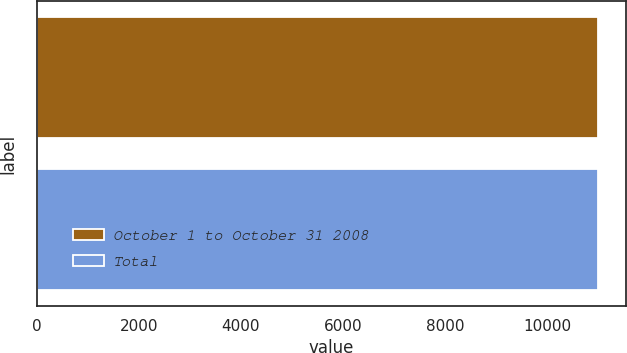Convert chart to OTSL. <chart><loc_0><loc_0><loc_500><loc_500><bar_chart><fcel>October 1 to October 31 2008<fcel>Total<nl><fcel>11000<fcel>11000.1<nl></chart> 